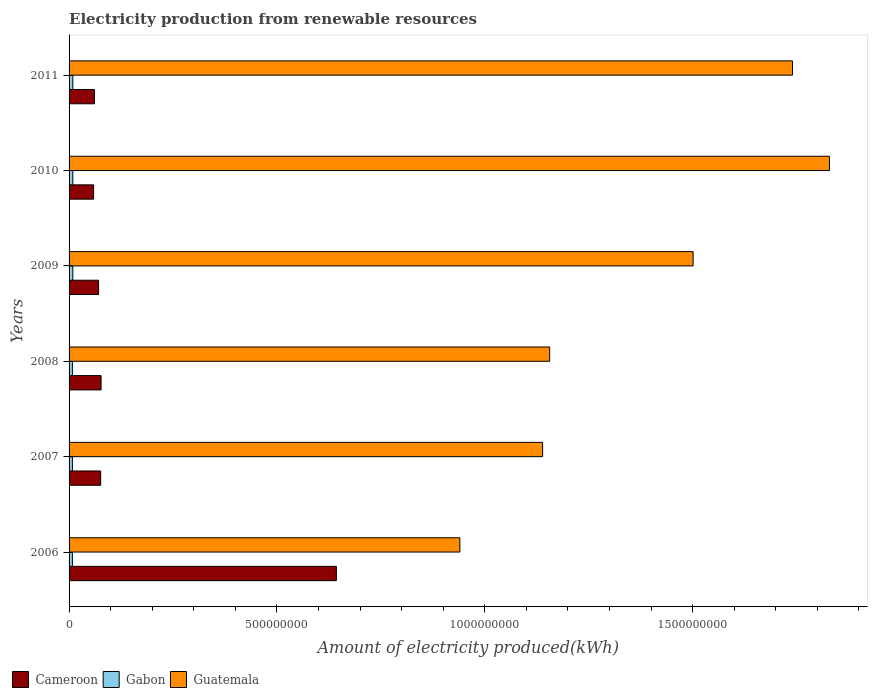How many groups of bars are there?
Keep it short and to the point. 6. Are the number of bars on each tick of the Y-axis equal?
Give a very brief answer. Yes. How many bars are there on the 3rd tick from the top?
Ensure brevity in your answer.  3. How many bars are there on the 3rd tick from the bottom?
Ensure brevity in your answer.  3. What is the label of the 3rd group of bars from the top?
Keep it short and to the point. 2009. In how many cases, is the number of bars for a given year not equal to the number of legend labels?
Your response must be concise. 0. What is the amount of electricity produced in Guatemala in 2009?
Your answer should be compact. 1.50e+09. Across all years, what is the maximum amount of electricity produced in Cameroon?
Provide a succinct answer. 6.43e+08. Across all years, what is the minimum amount of electricity produced in Cameroon?
Give a very brief answer. 5.90e+07. In which year was the amount of electricity produced in Guatemala maximum?
Offer a terse response. 2010. In which year was the amount of electricity produced in Cameroon minimum?
Ensure brevity in your answer.  2010. What is the total amount of electricity produced in Gabon in the graph?
Make the answer very short. 5.10e+07. What is the difference between the amount of electricity produced in Gabon in 2007 and that in 2011?
Your response must be concise. -1.00e+06. What is the difference between the amount of electricity produced in Guatemala in 2011 and the amount of electricity produced in Cameroon in 2008?
Your response must be concise. 1.66e+09. What is the average amount of electricity produced in Cameroon per year?
Your response must be concise. 1.64e+08. In the year 2010, what is the difference between the amount of electricity produced in Cameroon and amount of electricity produced in Gabon?
Your answer should be compact. 5.00e+07. What is the ratio of the amount of electricity produced in Guatemala in 2006 to that in 2009?
Offer a very short reply. 0.63. Is the difference between the amount of electricity produced in Cameroon in 2007 and 2008 greater than the difference between the amount of electricity produced in Gabon in 2007 and 2008?
Offer a very short reply. No. What is the difference between the highest and the second highest amount of electricity produced in Guatemala?
Keep it short and to the point. 8.90e+07. What is the difference between the highest and the lowest amount of electricity produced in Gabon?
Offer a very short reply. 1.00e+06. In how many years, is the amount of electricity produced in Cameroon greater than the average amount of electricity produced in Cameroon taken over all years?
Keep it short and to the point. 1. Is the sum of the amount of electricity produced in Gabon in 2009 and 2010 greater than the maximum amount of electricity produced in Cameroon across all years?
Give a very brief answer. No. What does the 1st bar from the top in 2009 represents?
Keep it short and to the point. Guatemala. What does the 2nd bar from the bottom in 2009 represents?
Give a very brief answer. Gabon. Are all the bars in the graph horizontal?
Your response must be concise. Yes. What is the difference between two consecutive major ticks on the X-axis?
Your response must be concise. 5.00e+08. Are the values on the major ticks of X-axis written in scientific E-notation?
Your answer should be compact. No. Does the graph contain any zero values?
Provide a succinct answer. No. Does the graph contain grids?
Your response must be concise. No. Where does the legend appear in the graph?
Keep it short and to the point. Bottom left. How many legend labels are there?
Offer a very short reply. 3. How are the legend labels stacked?
Provide a succinct answer. Horizontal. What is the title of the graph?
Your answer should be very brief. Electricity production from renewable resources. What is the label or title of the X-axis?
Your response must be concise. Amount of electricity produced(kWh). What is the Amount of electricity produced(kWh) of Cameroon in 2006?
Your response must be concise. 6.43e+08. What is the Amount of electricity produced(kWh) in Gabon in 2006?
Your response must be concise. 8.00e+06. What is the Amount of electricity produced(kWh) of Guatemala in 2006?
Offer a terse response. 9.40e+08. What is the Amount of electricity produced(kWh) in Cameroon in 2007?
Offer a very short reply. 7.60e+07. What is the Amount of electricity produced(kWh) in Gabon in 2007?
Provide a succinct answer. 8.00e+06. What is the Amount of electricity produced(kWh) in Guatemala in 2007?
Offer a terse response. 1.14e+09. What is the Amount of electricity produced(kWh) of Cameroon in 2008?
Your answer should be compact. 7.70e+07. What is the Amount of electricity produced(kWh) of Guatemala in 2008?
Provide a succinct answer. 1.16e+09. What is the Amount of electricity produced(kWh) in Cameroon in 2009?
Give a very brief answer. 7.10e+07. What is the Amount of electricity produced(kWh) in Gabon in 2009?
Provide a succinct answer. 9.00e+06. What is the Amount of electricity produced(kWh) of Guatemala in 2009?
Offer a very short reply. 1.50e+09. What is the Amount of electricity produced(kWh) of Cameroon in 2010?
Provide a short and direct response. 5.90e+07. What is the Amount of electricity produced(kWh) in Gabon in 2010?
Your answer should be compact. 9.00e+06. What is the Amount of electricity produced(kWh) of Guatemala in 2010?
Your answer should be very brief. 1.83e+09. What is the Amount of electricity produced(kWh) in Cameroon in 2011?
Offer a very short reply. 6.10e+07. What is the Amount of electricity produced(kWh) of Gabon in 2011?
Provide a succinct answer. 9.00e+06. What is the Amount of electricity produced(kWh) of Guatemala in 2011?
Ensure brevity in your answer.  1.74e+09. Across all years, what is the maximum Amount of electricity produced(kWh) in Cameroon?
Provide a short and direct response. 6.43e+08. Across all years, what is the maximum Amount of electricity produced(kWh) of Gabon?
Provide a short and direct response. 9.00e+06. Across all years, what is the maximum Amount of electricity produced(kWh) in Guatemala?
Keep it short and to the point. 1.83e+09. Across all years, what is the minimum Amount of electricity produced(kWh) of Cameroon?
Make the answer very short. 5.90e+07. Across all years, what is the minimum Amount of electricity produced(kWh) of Gabon?
Offer a very short reply. 8.00e+06. Across all years, what is the minimum Amount of electricity produced(kWh) of Guatemala?
Make the answer very short. 9.40e+08. What is the total Amount of electricity produced(kWh) of Cameroon in the graph?
Keep it short and to the point. 9.87e+08. What is the total Amount of electricity produced(kWh) in Gabon in the graph?
Offer a terse response. 5.10e+07. What is the total Amount of electricity produced(kWh) of Guatemala in the graph?
Make the answer very short. 8.30e+09. What is the difference between the Amount of electricity produced(kWh) in Cameroon in 2006 and that in 2007?
Make the answer very short. 5.67e+08. What is the difference between the Amount of electricity produced(kWh) in Gabon in 2006 and that in 2007?
Your response must be concise. 0. What is the difference between the Amount of electricity produced(kWh) in Guatemala in 2006 and that in 2007?
Your answer should be very brief. -1.99e+08. What is the difference between the Amount of electricity produced(kWh) in Cameroon in 2006 and that in 2008?
Provide a short and direct response. 5.66e+08. What is the difference between the Amount of electricity produced(kWh) in Gabon in 2006 and that in 2008?
Keep it short and to the point. 0. What is the difference between the Amount of electricity produced(kWh) of Guatemala in 2006 and that in 2008?
Your answer should be very brief. -2.16e+08. What is the difference between the Amount of electricity produced(kWh) in Cameroon in 2006 and that in 2009?
Ensure brevity in your answer.  5.72e+08. What is the difference between the Amount of electricity produced(kWh) in Gabon in 2006 and that in 2009?
Offer a very short reply. -1.00e+06. What is the difference between the Amount of electricity produced(kWh) in Guatemala in 2006 and that in 2009?
Ensure brevity in your answer.  -5.61e+08. What is the difference between the Amount of electricity produced(kWh) in Cameroon in 2006 and that in 2010?
Provide a succinct answer. 5.84e+08. What is the difference between the Amount of electricity produced(kWh) of Gabon in 2006 and that in 2010?
Give a very brief answer. -1.00e+06. What is the difference between the Amount of electricity produced(kWh) in Guatemala in 2006 and that in 2010?
Make the answer very short. -8.89e+08. What is the difference between the Amount of electricity produced(kWh) of Cameroon in 2006 and that in 2011?
Make the answer very short. 5.82e+08. What is the difference between the Amount of electricity produced(kWh) in Gabon in 2006 and that in 2011?
Make the answer very short. -1.00e+06. What is the difference between the Amount of electricity produced(kWh) in Guatemala in 2006 and that in 2011?
Your answer should be compact. -8.00e+08. What is the difference between the Amount of electricity produced(kWh) of Cameroon in 2007 and that in 2008?
Your answer should be very brief. -1.00e+06. What is the difference between the Amount of electricity produced(kWh) of Guatemala in 2007 and that in 2008?
Keep it short and to the point. -1.70e+07. What is the difference between the Amount of electricity produced(kWh) of Cameroon in 2007 and that in 2009?
Give a very brief answer. 5.00e+06. What is the difference between the Amount of electricity produced(kWh) of Gabon in 2007 and that in 2009?
Your answer should be compact. -1.00e+06. What is the difference between the Amount of electricity produced(kWh) of Guatemala in 2007 and that in 2009?
Give a very brief answer. -3.62e+08. What is the difference between the Amount of electricity produced(kWh) of Cameroon in 2007 and that in 2010?
Offer a terse response. 1.70e+07. What is the difference between the Amount of electricity produced(kWh) of Guatemala in 2007 and that in 2010?
Your answer should be very brief. -6.90e+08. What is the difference between the Amount of electricity produced(kWh) in Cameroon in 2007 and that in 2011?
Give a very brief answer. 1.50e+07. What is the difference between the Amount of electricity produced(kWh) of Guatemala in 2007 and that in 2011?
Provide a short and direct response. -6.01e+08. What is the difference between the Amount of electricity produced(kWh) of Guatemala in 2008 and that in 2009?
Provide a short and direct response. -3.45e+08. What is the difference between the Amount of electricity produced(kWh) of Cameroon in 2008 and that in 2010?
Give a very brief answer. 1.80e+07. What is the difference between the Amount of electricity produced(kWh) in Guatemala in 2008 and that in 2010?
Make the answer very short. -6.73e+08. What is the difference between the Amount of electricity produced(kWh) of Cameroon in 2008 and that in 2011?
Give a very brief answer. 1.60e+07. What is the difference between the Amount of electricity produced(kWh) in Gabon in 2008 and that in 2011?
Provide a succinct answer. -1.00e+06. What is the difference between the Amount of electricity produced(kWh) of Guatemala in 2008 and that in 2011?
Provide a succinct answer. -5.84e+08. What is the difference between the Amount of electricity produced(kWh) of Guatemala in 2009 and that in 2010?
Give a very brief answer. -3.28e+08. What is the difference between the Amount of electricity produced(kWh) of Cameroon in 2009 and that in 2011?
Keep it short and to the point. 1.00e+07. What is the difference between the Amount of electricity produced(kWh) of Gabon in 2009 and that in 2011?
Give a very brief answer. 0. What is the difference between the Amount of electricity produced(kWh) of Guatemala in 2009 and that in 2011?
Provide a short and direct response. -2.39e+08. What is the difference between the Amount of electricity produced(kWh) in Cameroon in 2010 and that in 2011?
Give a very brief answer. -2.00e+06. What is the difference between the Amount of electricity produced(kWh) of Gabon in 2010 and that in 2011?
Your response must be concise. 0. What is the difference between the Amount of electricity produced(kWh) in Guatemala in 2010 and that in 2011?
Your response must be concise. 8.90e+07. What is the difference between the Amount of electricity produced(kWh) of Cameroon in 2006 and the Amount of electricity produced(kWh) of Gabon in 2007?
Provide a succinct answer. 6.35e+08. What is the difference between the Amount of electricity produced(kWh) of Cameroon in 2006 and the Amount of electricity produced(kWh) of Guatemala in 2007?
Your response must be concise. -4.96e+08. What is the difference between the Amount of electricity produced(kWh) of Gabon in 2006 and the Amount of electricity produced(kWh) of Guatemala in 2007?
Provide a succinct answer. -1.13e+09. What is the difference between the Amount of electricity produced(kWh) of Cameroon in 2006 and the Amount of electricity produced(kWh) of Gabon in 2008?
Provide a succinct answer. 6.35e+08. What is the difference between the Amount of electricity produced(kWh) of Cameroon in 2006 and the Amount of electricity produced(kWh) of Guatemala in 2008?
Provide a succinct answer. -5.13e+08. What is the difference between the Amount of electricity produced(kWh) in Gabon in 2006 and the Amount of electricity produced(kWh) in Guatemala in 2008?
Your answer should be compact. -1.15e+09. What is the difference between the Amount of electricity produced(kWh) of Cameroon in 2006 and the Amount of electricity produced(kWh) of Gabon in 2009?
Your response must be concise. 6.34e+08. What is the difference between the Amount of electricity produced(kWh) in Cameroon in 2006 and the Amount of electricity produced(kWh) in Guatemala in 2009?
Ensure brevity in your answer.  -8.58e+08. What is the difference between the Amount of electricity produced(kWh) of Gabon in 2006 and the Amount of electricity produced(kWh) of Guatemala in 2009?
Provide a succinct answer. -1.49e+09. What is the difference between the Amount of electricity produced(kWh) in Cameroon in 2006 and the Amount of electricity produced(kWh) in Gabon in 2010?
Provide a succinct answer. 6.34e+08. What is the difference between the Amount of electricity produced(kWh) of Cameroon in 2006 and the Amount of electricity produced(kWh) of Guatemala in 2010?
Offer a terse response. -1.19e+09. What is the difference between the Amount of electricity produced(kWh) in Gabon in 2006 and the Amount of electricity produced(kWh) in Guatemala in 2010?
Ensure brevity in your answer.  -1.82e+09. What is the difference between the Amount of electricity produced(kWh) in Cameroon in 2006 and the Amount of electricity produced(kWh) in Gabon in 2011?
Give a very brief answer. 6.34e+08. What is the difference between the Amount of electricity produced(kWh) in Cameroon in 2006 and the Amount of electricity produced(kWh) in Guatemala in 2011?
Your answer should be very brief. -1.10e+09. What is the difference between the Amount of electricity produced(kWh) of Gabon in 2006 and the Amount of electricity produced(kWh) of Guatemala in 2011?
Offer a very short reply. -1.73e+09. What is the difference between the Amount of electricity produced(kWh) of Cameroon in 2007 and the Amount of electricity produced(kWh) of Gabon in 2008?
Your answer should be very brief. 6.80e+07. What is the difference between the Amount of electricity produced(kWh) of Cameroon in 2007 and the Amount of electricity produced(kWh) of Guatemala in 2008?
Your answer should be very brief. -1.08e+09. What is the difference between the Amount of electricity produced(kWh) of Gabon in 2007 and the Amount of electricity produced(kWh) of Guatemala in 2008?
Ensure brevity in your answer.  -1.15e+09. What is the difference between the Amount of electricity produced(kWh) of Cameroon in 2007 and the Amount of electricity produced(kWh) of Gabon in 2009?
Keep it short and to the point. 6.70e+07. What is the difference between the Amount of electricity produced(kWh) of Cameroon in 2007 and the Amount of electricity produced(kWh) of Guatemala in 2009?
Give a very brief answer. -1.42e+09. What is the difference between the Amount of electricity produced(kWh) in Gabon in 2007 and the Amount of electricity produced(kWh) in Guatemala in 2009?
Keep it short and to the point. -1.49e+09. What is the difference between the Amount of electricity produced(kWh) in Cameroon in 2007 and the Amount of electricity produced(kWh) in Gabon in 2010?
Keep it short and to the point. 6.70e+07. What is the difference between the Amount of electricity produced(kWh) of Cameroon in 2007 and the Amount of electricity produced(kWh) of Guatemala in 2010?
Keep it short and to the point. -1.75e+09. What is the difference between the Amount of electricity produced(kWh) in Gabon in 2007 and the Amount of electricity produced(kWh) in Guatemala in 2010?
Provide a short and direct response. -1.82e+09. What is the difference between the Amount of electricity produced(kWh) of Cameroon in 2007 and the Amount of electricity produced(kWh) of Gabon in 2011?
Your response must be concise. 6.70e+07. What is the difference between the Amount of electricity produced(kWh) in Cameroon in 2007 and the Amount of electricity produced(kWh) in Guatemala in 2011?
Your response must be concise. -1.66e+09. What is the difference between the Amount of electricity produced(kWh) in Gabon in 2007 and the Amount of electricity produced(kWh) in Guatemala in 2011?
Provide a short and direct response. -1.73e+09. What is the difference between the Amount of electricity produced(kWh) of Cameroon in 2008 and the Amount of electricity produced(kWh) of Gabon in 2009?
Make the answer very short. 6.80e+07. What is the difference between the Amount of electricity produced(kWh) of Cameroon in 2008 and the Amount of electricity produced(kWh) of Guatemala in 2009?
Your answer should be compact. -1.42e+09. What is the difference between the Amount of electricity produced(kWh) of Gabon in 2008 and the Amount of electricity produced(kWh) of Guatemala in 2009?
Make the answer very short. -1.49e+09. What is the difference between the Amount of electricity produced(kWh) of Cameroon in 2008 and the Amount of electricity produced(kWh) of Gabon in 2010?
Make the answer very short. 6.80e+07. What is the difference between the Amount of electricity produced(kWh) of Cameroon in 2008 and the Amount of electricity produced(kWh) of Guatemala in 2010?
Give a very brief answer. -1.75e+09. What is the difference between the Amount of electricity produced(kWh) in Gabon in 2008 and the Amount of electricity produced(kWh) in Guatemala in 2010?
Your response must be concise. -1.82e+09. What is the difference between the Amount of electricity produced(kWh) of Cameroon in 2008 and the Amount of electricity produced(kWh) of Gabon in 2011?
Ensure brevity in your answer.  6.80e+07. What is the difference between the Amount of electricity produced(kWh) in Cameroon in 2008 and the Amount of electricity produced(kWh) in Guatemala in 2011?
Your answer should be very brief. -1.66e+09. What is the difference between the Amount of electricity produced(kWh) of Gabon in 2008 and the Amount of electricity produced(kWh) of Guatemala in 2011?
Provide a succinct answer. -1.73e+09. What is the difference between the Amount of electricity produced(kWh) in Cameroon in 2009 and the Amount of electricity produced(kWh) in Gabon in 2010?
Your answer should be very brief. 6.20e+07. What is the difference between the Amount of electricity produced(kWh) of Cameroon in 2009 and the Amount of electricity produced(kWh) of Guatemala in 2010?
Make the answer very short. -1.76e+09. What is the difference between the Amount of electricity produced(kWh) of Gabon in 2009 and the Amount of electricity produced(kWh) of Guatemala in 2010?
Your answer should be very brief. -1.82e+09. What is the difference between the Amount of electricity produced(kWh) of Cameroon in 2009 and the Amount of electricity produced(kWh) of Gabon in 2011?
Provide a short and direct response. 6.20e+07. What is the difference between the Amount of electricity produced(kWh) of Cameroon in 2009 and the Amount of electricity produced(kWh) of Guatemala in 2011?
Keep it short and to the point. -1.67e+09. What is the difference between the Amount of electricity produced(kWh) of Gabon in 2009 and the Amount of electricity produced(kWh) of Guatemala in 2011?
Ensure brevity in your answer.  -1.73e+09. What is the difference between the Amount of electricity produced(kWh) in Cameroon in 2010 and the Amount of electricity produced(kWh) in Gabon in 2011?
Your answer should be compact. 5.00e+07. What is the difference between the Amount of electricity produced(kWh) of Cameroon in 2010 and the Amount of electricity produced(kWh) of Guatemala in 2011?
Your answer should be very brief. -1.68e+09. What is the difference between the Amount of electricity produced(kWh) in Gabon in 2010 and the Amount of electricity produced(kWh) in Guatemala in 2011?
Provide a short and direct response. -1.73e+09. What is the average Amount of electricity produced(kWh) of Cameroon per year?
Your answer should be compact. 1.64e+08. What is the average Amount of electricity produced(kWh) in Gabon per year?
Your answer should be very brief. 8.50e+06. What is the average Amount of electricity produced(kWh) in Guatemala per year?
Provide a short and direct response. 1.38e+09. In the year 2006, what is the difference between the Amount of electricity produced(kWh) of Cameroon and Amount of electricity produced(kWh) of Gabon?
Your answer should be compact. 6.35e+08. In the year 2006, what is the difference between the Amount of electricity produced(kWh) in Cameroon and Amount of electricity produced(kWh) in Guatemala?
Provide a succinct answer. -2.97e+08. In the year 2006, what is the difference between the Amount of electricity produced(kWh) in Gabon and Amount of electricity produced(kWh) in Guatemala?
Keep it short and to the point. -9.32e+08. In the year 2007, what is the difference between the Amount of electricity produced(kWh) of Cameroon and Amount of electricity produced(kWh) of Gabon?
Offer a terse response. 6.80e+07. In the year 2007, what is the difference between the Amount of electricity produced(kWh) in Cameroon and Amount of electricity produced(kWh) in Guatemala?
Your response must be concise. -1.06e+09. In the year 2007, what is the difference between the Amount of electricity produced(kWh) of Gabon and Amount of electricity produced(kWh) of Guatemala?
Ensure brevity in your answer.  -1.13e+09. In the year 2008, what is the difference between the Amount of electricity produced(kWh) of Cameroon and Amount of electricity produced(kWh) of Gabon?
Your answer should be compact. 6.90e+07. In the year 2008, what is the difference between the Amount of electricity produced(kWh) in Cameroon and Amount of electricity produced(kWh) in Guatemala?
Your response must be concise. -1.08e+09. In the year 2008, what is the difference between the Amount of electricity produced(kWh) of Gabon and Amount of electricity produced(kWh) of Guatemala?
Provide a succinct answer. -1.15e+09. In the year 2009, what is the difference between the Amount of electricity produced(kWh) in Cameroon and Amount of electricity produced(kWh) in Gabon?
Provide a succinct answer. 6.20e+07. In the year 2009, what is the difference between the Amount of electricity produced(kWh) of Cameroon and Amount of electricity produced(kWh) of Guatemala?
Make the answer very short. -1.43e+09. In the year 2009, what is the difference between the Amount of electricity produced(kWh) of Gabon and Amount of electricity produced(kWh) of Guatemala?
Your answer should be very brief. -1.49e+09. In the year 2010, what is the difference between the Amount of electricity produced(kWh) in Cameroon and Amount of electricity produced(kWh) in Gabon?
Your answer should be very brief. 5.00e+07. In the year 2010, what is the difference between the Amount of electricity produced(kWh) of Cameroon and Amount of electricity produced(kWh) of Guatemala?
Offer a terse response. -1.77e+09. In the year 2010, what is the difference between the Amount of electricity produced(kWh) in Gabon and Amount of electricity produced(kWh) in Guatemala?
Offer a terse response. -1.82e+09. In the year 2011, what is the difference between the Amount of electricity produced(kWh) of Cameroon and Amount of electricity produced(kWh) of Gabon?
Offer a terse response. 5.20e+07. In the year 2011, what is the difference between the Amount of electricity produced(kWh) of Cameroon and Amount of electricity produced(kWh) of Guatemala?
Give a very brief answer. -1.68e+09. In the year 2011, what is the difference between the Amount of electricity produced(kWh) in Gabon and Amount of electricity produced(kWh) in Guatemala?
Your answer should be compact. -1.73e+09. What is the ratio of the Amount of electricity produced(kWh) of Cameroon in 2006 to that in 2007?
Offer a terse response. 8.46. What is the ratio of the Amount of electricity produced(kWh) of Gabon in 2006 to that in 2007?
Keep it short and to the point. 1. What is the ratio of the Amount of electricity produced(kWh) of Guatemala in 2006 to that in 2007?
Your response must be concise. 0.83. What is the ratio of the Amount of electricity produced(kWh) in Cameroon in 2006 to that in 2008?
Your response must be concise. 8.35. What is the ratio of the Amount of electricity produced(kWh) of Guatemala in 2006 to that in 2008?
Your answer should be compact. 0.81. What is the ratio of the Amount of electricity produced(kWh) of Cameroon in 2006 to that in 2009?
Provide a succinct answer. 9.06. What is the ratio of the Amount of electricity produced(kWh) of Guatemala in 2006 to that in 2009?
Offer a terse response. 0.63. What is the ratio of the Amount of electricity produced(kWh) in Cameroon in 2006 to that in 2010?
Keep it short and to the point. 10.9. What is the ratio of the Amount of electricity produced(kWh) in Guatemala in 2006 to that in 2010?
Your answer should be compact. 0.51. What is the ratio of the Amount of electricity produced(kWh) of Cameroon in 2006 to that in 2011?
Your response must be concise. 10.54. What is the ratio of the Amount of electricity produced(kWh) of Gabon in 2006 to that in 2011?
Keep it short and to the point. 0.89. What is the ratio of the Amount of electricity produced(kWh) in Guatemala in 2006 to that in 2011?
Your answer should be compact. 0.54. What is the ratio of the Amount of electricity produced(kWh) in Gabon in 2007 to that in 2008?
Provide a short and direct response. 1. What is the ratio of the Amount of electricity produced(kWh) in Guatemala in 2007 to that in 2008?
Keep it short and to the point. 0.99. What is the ratio of the Amount of electricity produced(kWh) in Cameroon in 2007 to that in 2009?
Ensure brevity in your answer.  1.07. What is the ratio of the Amount of electricity produced(kWh) of Gabon in 2007 to that in 2009?
Provide a succinct answer. 0.89. What is the ratio of the Amount of electricity produced(kWh) in Guatemala in 2007 to that in 2009?
Make the answer very short. 0.76. What is the ratio of the Amount of electricity produced(kWh) in Cameroon in 2007 to that in 2010?
Make the answer very short. 1.29. What is the ratio of the Amount of electricity produced(kWh) in Gabon in 2007 to that in 2010?
Your answer should be compact. 0.89. What is the ratio of the Amount of electricity produced(kWh) of Guatemala in 2007 to that in 2010?
Provide a succinct answer. 0.62. What is the ratio of the Amount of electricity produced(kWh) of Cameroon in 2007 to that in 2011?
Offer a terse response. 1.25. What is the ratio of the Amount of electricity produced(kWh) of Guatemala in 2007 to that in 2011?
Your answer should be compact. 0.65. What is the ratio of the Amount of electricity produced(kWh) of Cameroon in 2008 to that in 2009?
Give a very brief answer. 1.08. What is the ratio of the Amount of electricity produced(kWh) in Gabon in 2008 to that in 2009?
Your response must be concise. 0.89. What is the ratio of the Amount of electricity produced(kWh) of Guatemala in 2008 to that in 2009?
Your response must be concise. 0.77. What is the ratio of the Amount of electricity produced(kWh) of Cameroon in 2008 to that in 2010?
Ensure brevity in your answer.  1.31. What is the ratio of the Amount of electricity produced(kWh) in Gabon in 2008 to that in 2010?
Your answer should be compact. 0.89. What is the ratio of the Amount of electricity produced(kWh) in Guatemala in 2008 to that in 2010?
Make the answer very short. 0.63. What is the ratio of the Amount of electricity produced(kWh) of Cameroon in 2008 to that in 2011?
Give a very brief answer. 1.26. What is the ratio of the Amount of electricity produced(kWh) in Guatemala in 2008 to that in 2011?
Provide a short and direct response. 0.66. What is the ratio of the Amount of electricity produced(kWh) in Cameroon in 2009 to that in 2010?
Provide a succinct answer. 1.2. What is the ratio of the Amount of electricity produced(kWh) of Guatemala in 2009 to that in 2010?
Your response must be concise. 0.82. What is the ratio of the Amount of electricity produced(kWh) in Cameroon in 2009 to that in 2011?
Ensure brevity in your answer.  1.16. What is the ratio of the Amount of electricity produced(kWh) of Gabon in 2009 to that in 2011?
Ensure brevity in your answer.  1. What is the ratio of the Amount of electricity produced(kWh) in Guatemala in 2009 to that in 2011?
Offer a very short reply. 0.86. What is the ratio of the Amount of electricity produced(kWh) in Cameroon in 2010 to that in 2011?
Ensure brevity in your answer.  0.97. What is the ratio of the Amount of electricity produced(kWh) of Gabon in 2010 to that in 2011?
Offer a terse response. 1. What is the ratio of the Amount of electricity produced(kWh) of Guatemala in 2010 to that in 2011?
Your answer should be very brief. 1.05. What is the difference between the highest and the second highest Amount of electricity produced(kWh) in Cameroon?
Keep it short and to the point. 5.66e+08. What is the difference between the highest and the second highest Amount of electricity produced(kWh) in Gabon?
Your response must be concise. 0. What is the difference between the highest and the second highest Amount of electricity produced(kWh) of Guatemala?
Your answer should be compact. 8.90e+07. What is the difference between the highest and the lowest Amount of electricity produced(kWh) in Cameroon?
Your answer should be very brief. 5.84e+08. What is the difference between the highest and the lowest Amount of electricity produced(kWh) of Gabon?
Offer a terse response. 1.00e+06. What is the difference between the highest and the lowest Amount of electricity produced(kWh) of Guatemala?
Your answer should be very brief. 8.89e+08. 